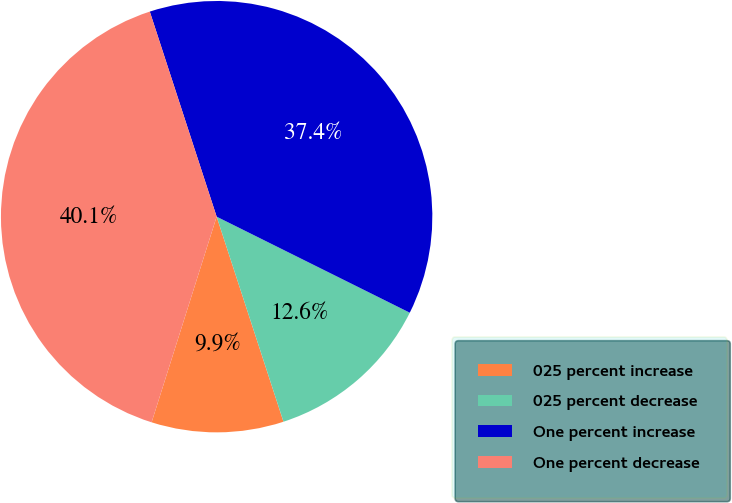<chart> <loc_0><loc_0><loc_500><loc_500><pie_chart><fcel>025 percent increase<fcel>025 percent decrease<fcel>One percent increase<fcel>One percent decrease<nl><fcel>9.89%<fcel>12.64%<fcel>37.36%<fcel>40.11%<nl></chart> 